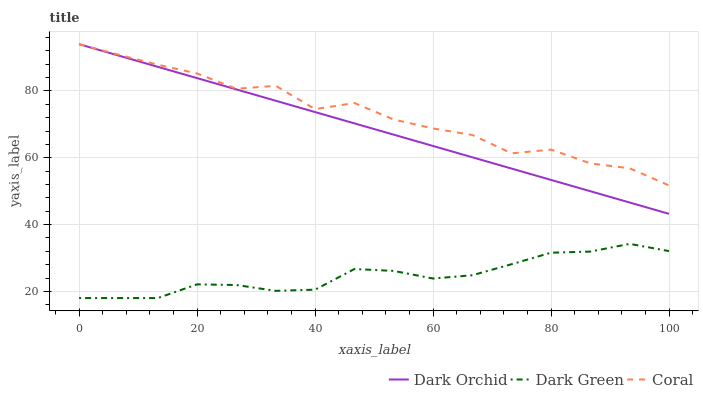Does Dark Green have the minimum area under the curve?
Answer yes or no. Yes. Does Coral have the maximum area under the curve?
Answer yes or no. Yes. Does Dark Orchid have the minimum area under the curve?
Answer yes or no. No. Does Dark Orchid have the maximum area under the curve?
Answer yes or no. No. Is Dark Orchid the smoothest?
Answer yes or no. Yes. Is Coral the roughest?
Answer yes or no. Yes. Is Dark Green the smoothest?
Answer yes or no. No. Is Dark Green the roughest?
Answer yes or no. No. Does Dark Green have the lowest value?
Answer yes or no. Yes. Does Dark Orchid have the lowest value?
Answer yes or no. No. Does Dark Orchid have the highest value?
Answer yes or no. Yes. Does Dark Green have the highest value?
Answer yes or no. No. Is Dark Green less than Dark Orchid?
Answer yes or no. Yes. Is Dark Orchid greater than Dark Green?
Answer yes or no. Yes. Does Dark Orchid intersect Coral?
Answer yes or no. Yes. Is Dark Orchid less than Coral?
Answer yes or no. No. Is Dark Orchid greater than Coral?
Answer yes or no. No. Does Dark Green intersect Dark Orchid?
Answer yes or no. No. 